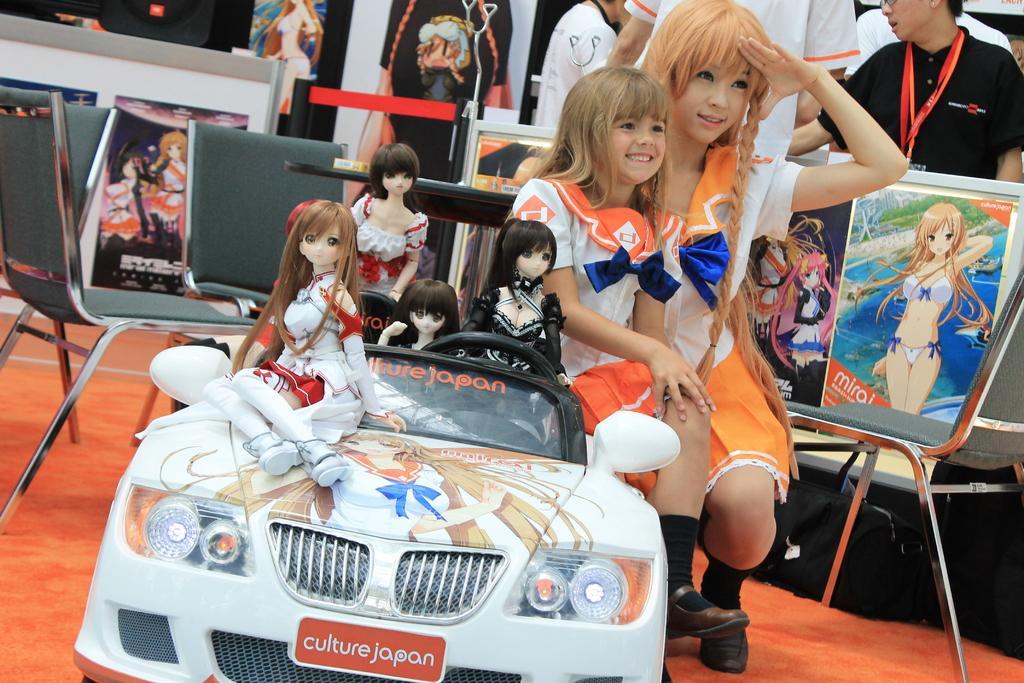Can you describe this image briefly? In this picture we can see two girls sitting on toy vehicles with toy girls on it and aside to that we have chair, table, some posters and woman. 